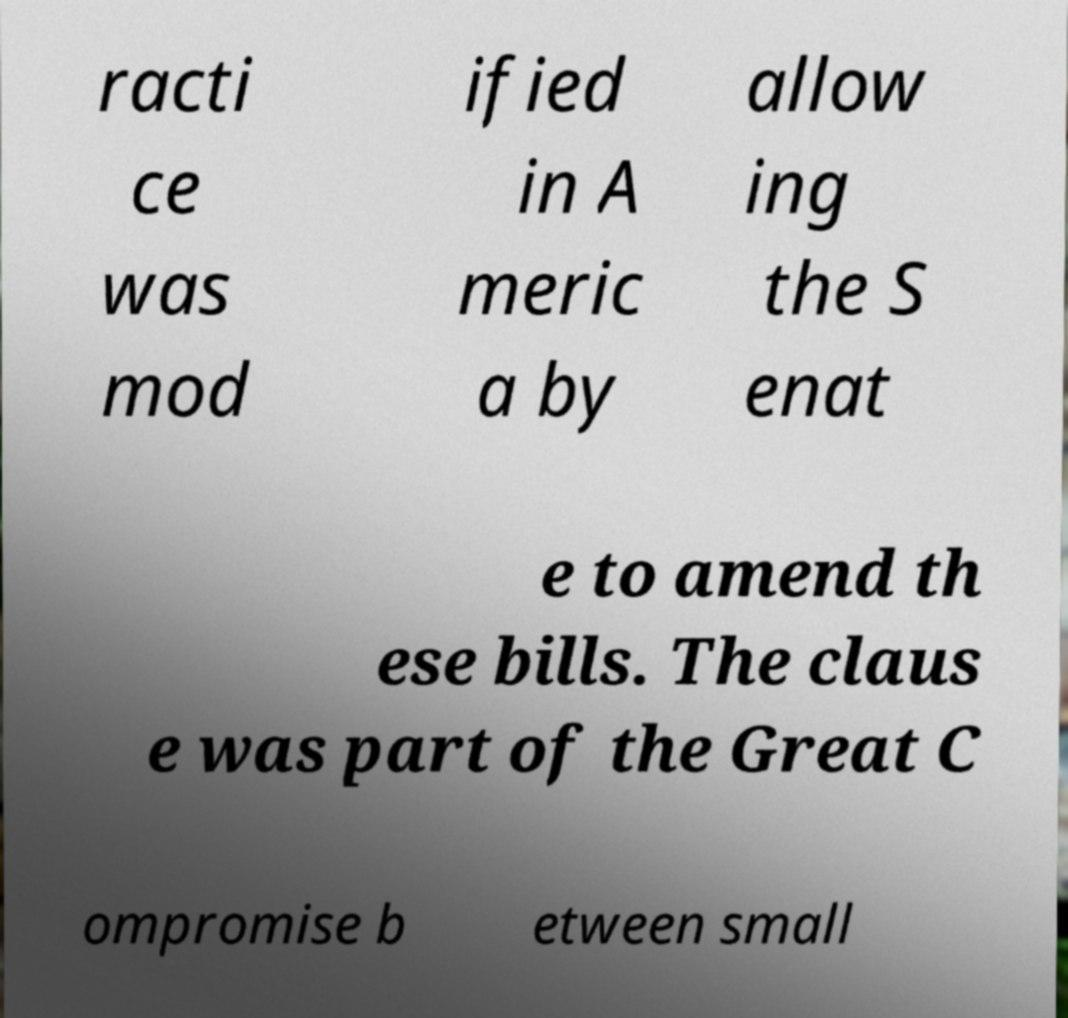There's text embedded in this image that I need extracted. Can you transcribe it verbatim? racti ce was mod ified in A meric a by allow ing the S enat e to amend th ese bills. The claus e was part of the Great C ompromise b etween small 